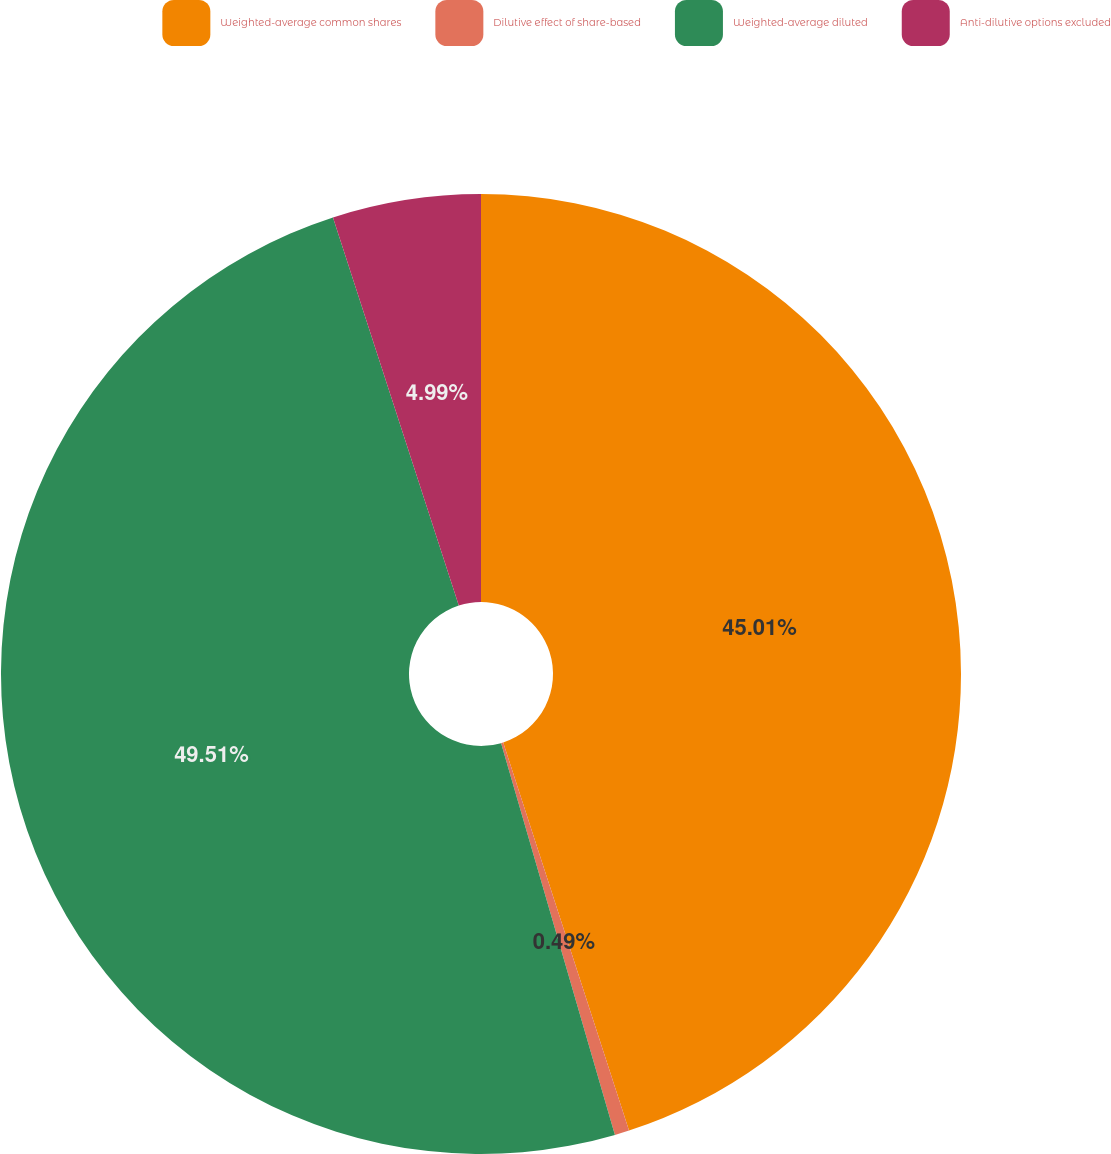<chart> <loc_0><loc_0><loc_500><loc_500><pie_chart><fcel>Weighted-average common shares<fcel>Dilutive effect of share-based<fcel>Weighted-average diluted<fcel>Anti-dilutive options excluded<nl><fcel>45.01%<fcel>0.49%<fcel>49.51%<fcel>4.99%<nl></chart> 